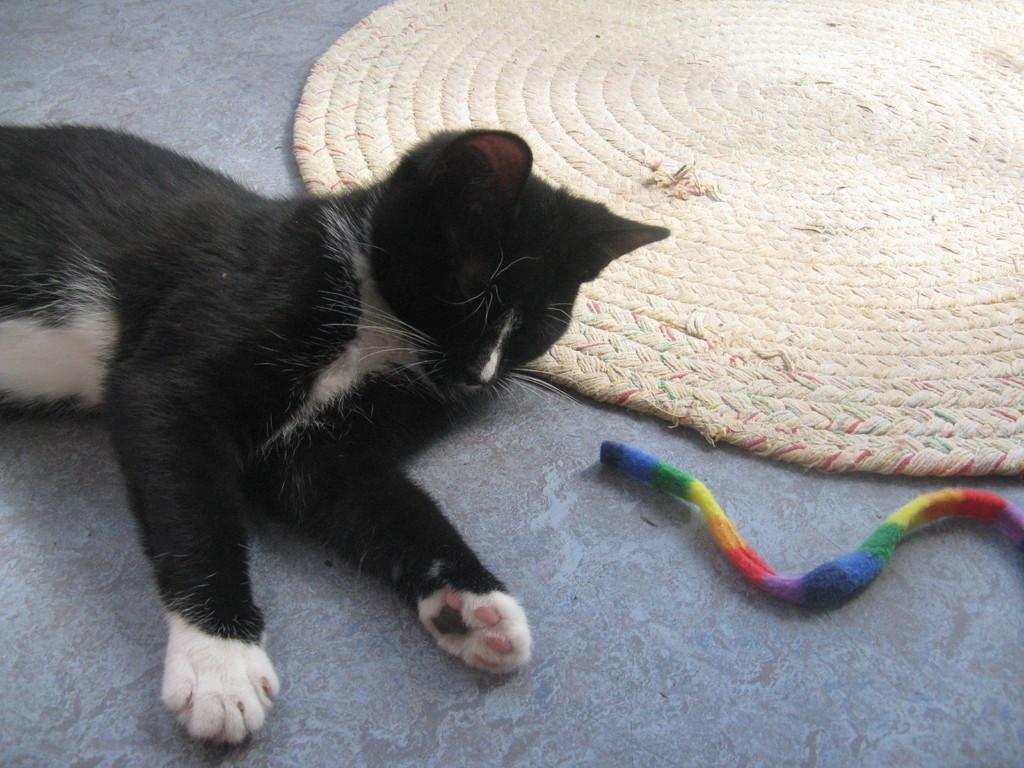What animal can be seen in the image? There is a cat in the image. What is the cat doing in the image? The cat is sleeping on the floor. What is located beside the cat? There is a mat beside the cat. What is in front of the cat? There is a thread with different colors in front of the cat. What type of office furniture can be seen in the image? There is no office furniture present in the image. What shape is the cat in the image? The cat is not a shape; it is a living animal. 